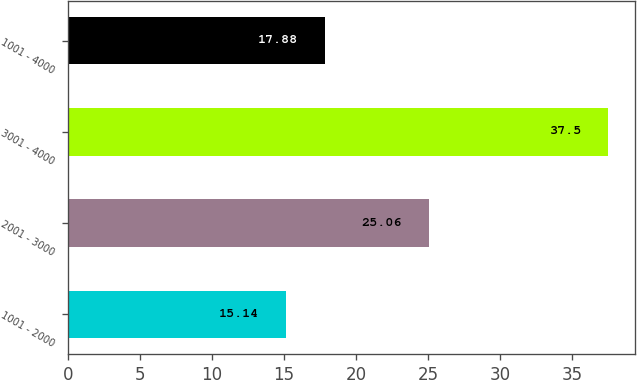<chart> <loc_0><loc_0><loc_500><loc_500><bar_chart><fcel>1001 - 2000<fcel>2001 - 3000<fcel>3001 - 4000<fcel>1001 - 4000<nl><fcel>15.14<fcel>25.06<fcel>37.5<fcel>17.88<nl></chart> 